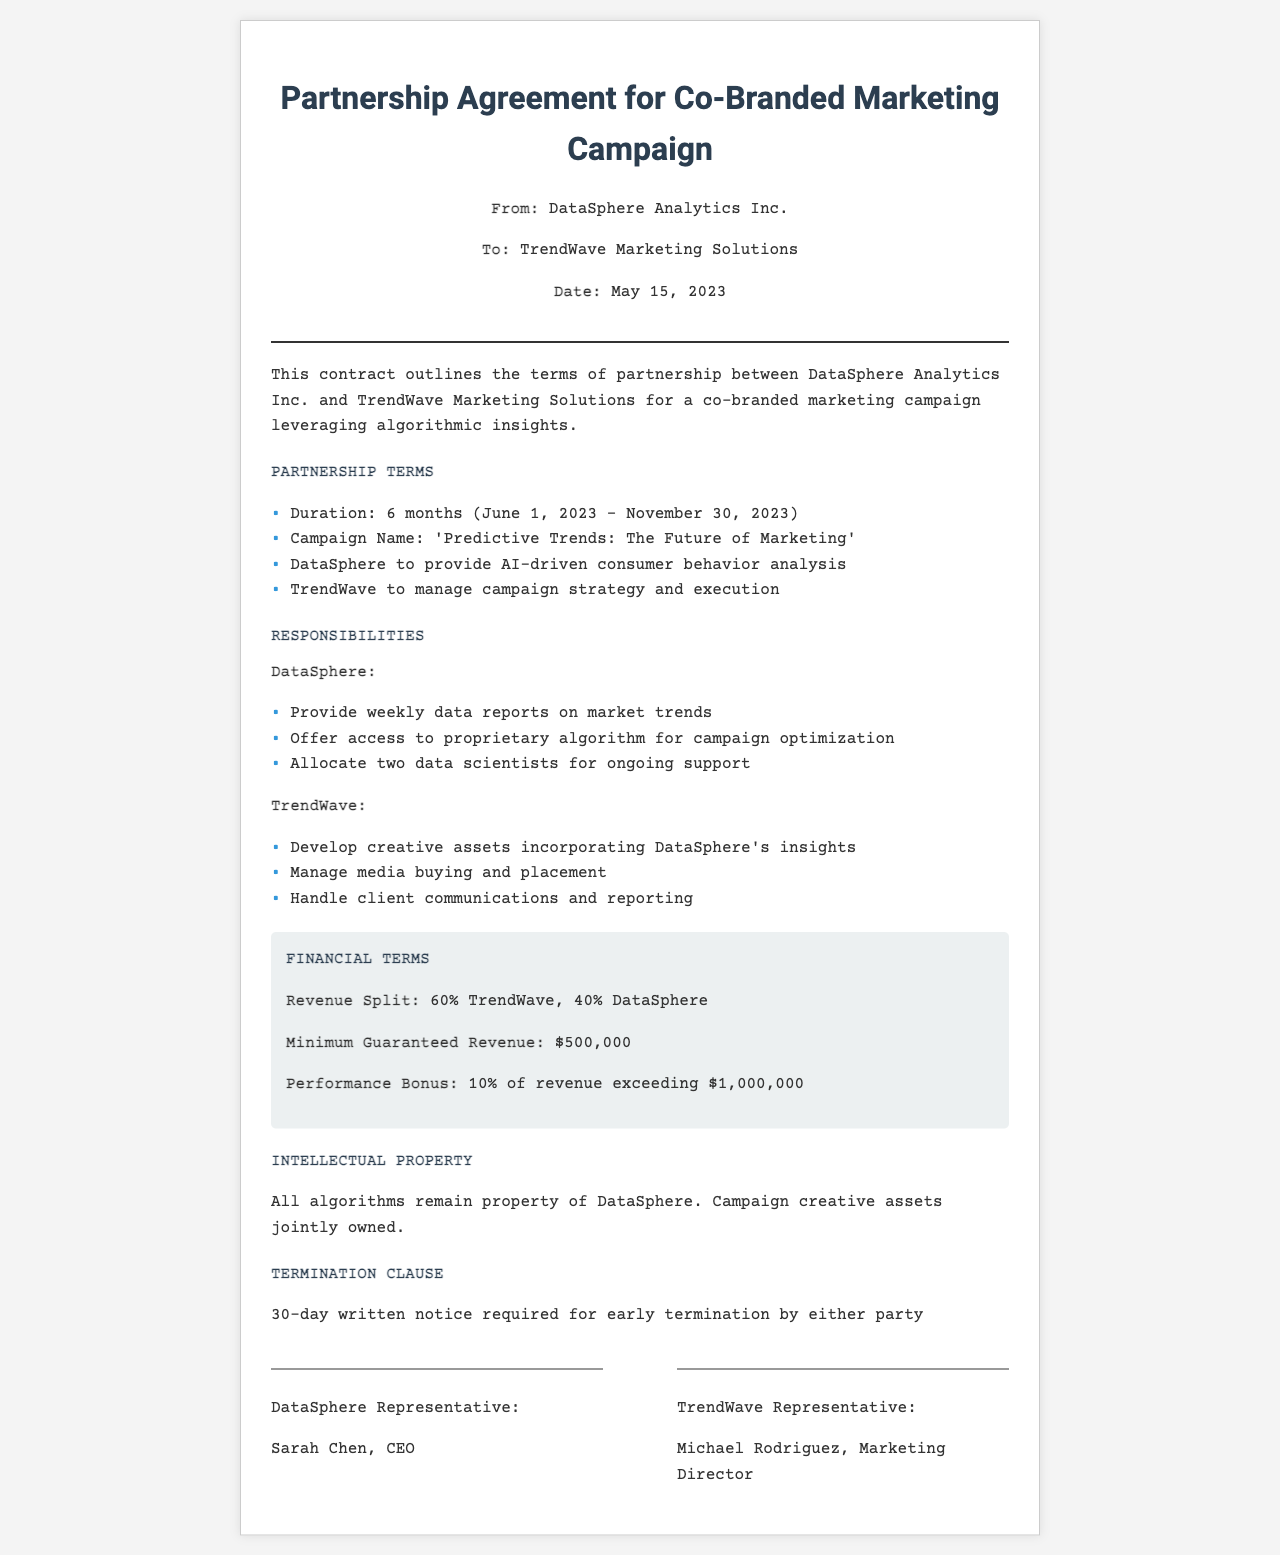What is the duration of the partnership? The duration is specified in the document as the time between June 1, 2023, and November 30, 2023.
Answer: 6 months What is the campaign name? The campaign name is mentioned in the document under the Partnership Terms section.
Answer: Predictive Trends: The Future of Marketing Who is the CEO of DataSphere? The document indicates the representative for DataSphere is Sarah Chen, who holds the title of CEO.
Answer: Sarah Chen What is the revenue split between TrendWave and DataSphere? The Financial Terms section outlines the revenue split as specified in the contract.
Answer: 60% TrendWave, 40% DataSphere What is the minimum guaranteed revenue? The document states the minimum guaranteed revenue as part of the Financial Terms.
Answer: $500,000 What is the performance bonus percentage? The bonus percentage is outlined in the Financial Terms section regarding revenue exceeding $1,000,000.
Answer: 10% What notice period is required for termination? The termination clause specifies the notice period required to terminate the contract early.
Answer: 30 days Who manages the media buying and placement? The responsibilities section lists the tasks assigned to TrendWave, which includes media buying.
Answer: TrendWave What type of assets are jointly owned? The Intellectual Property section details ownership of campaign creative assets.
Answer: Campaign creative assets 